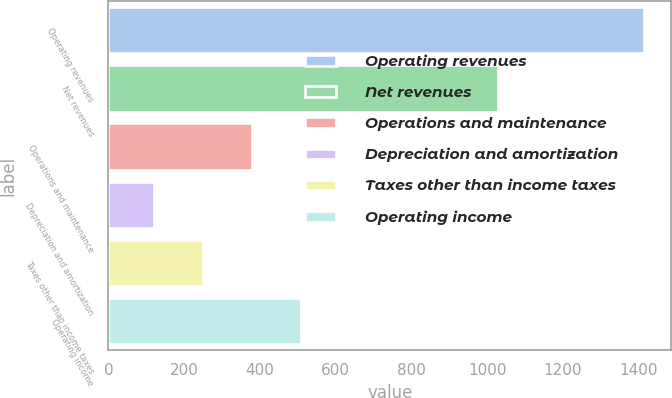<chart> <loc_0><loc_0><loc_500><loc_500><bar_chart><fcel>Operating revenues<fcel>Net revenues<fcel>Operations and maintenance<fcel>Depreciation and amortization<fcel>Taxes other than income taxes<fcel>Operating income<nl><fcel>1415<fcel>1028<fcel>379<fcel>120<fcel>249.5<fcel>508.5<nl></chart> 